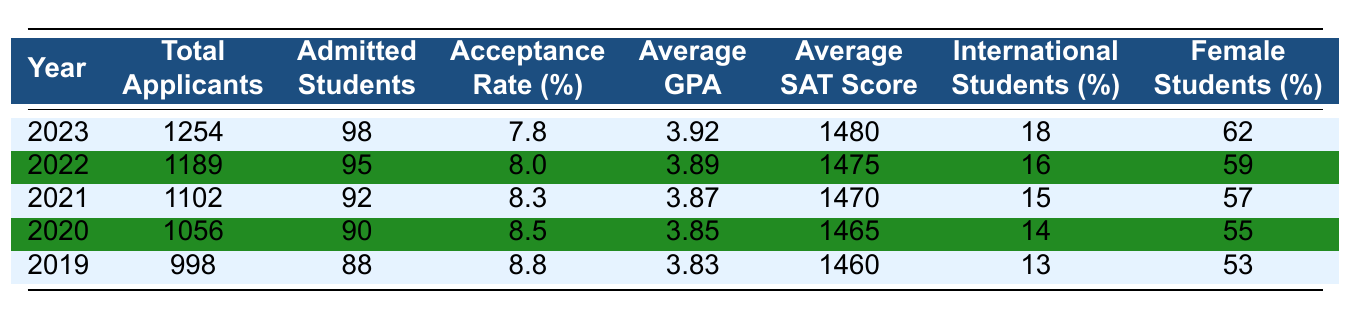What was the acceptance rate in 2023? The acceptance rate for 2023 is provided directly in the table under the corresponding column. It states 7.8%.
Answer: 7.8% How many total applicants were there in 2021? The number of total applicants for the year 2021 is listed directly in the table. It shows 1102 applicants.
Answer: 1102 What is the average GPA of admitted students in 2020? The average GPA for admitted students in 2020 is listed in the table as 3.85.
Answer: 3.85 What percentage of the students admitted in 2022 were female? The table specifies that 59% of the admitted students in 2022 were female.
Answer: 59% What was the total number of admitted students over the last five years? To find the total number of admitted students, sum the admitted students for all years: (98 + 95 + 92 + 90 + 88) = 463.
Answer: 463 What was the trend in acceptance rates from 2019 to 2023? By comparing the acceptance rates from each year in the table: 8.8% (2019), 8.5% (2020), 8.3% (2021), 8.0% (2022), and 7.8% (2023), we see a decreasing trend in acceptance rates over these years.
Answer: Decreasing How much did the average SAT score increase from 2019 to 2023? The average SAT score in 2019 was 1460 and in 2023 it was 1480. The increase is calculated as 1480 - 1460 = 20.
Answer: 20 What is the percentage of international students in 2022 compared to 2023? The percentage of international students in 2022 is 16% and in 2023 it is 18%. Comparing these, 18% (2023) - 16% (2022) = 2% increase but the question asks for the comparison. So, 18% is higher than 16%.
Answer: Yes Calculate the average acceptance rate over the last 5 years. The acceptance rates for the years are 7.8%, 8.0%, 8.3%, 8.5%, and 8.8%. To find the average: (7.8 + 8.0 + 8.3 + 8.5 + 8.8) / 5 = 8.24%.
Answer: 8.24% Was the average GPA of admitted students higher in 2023 than in 2020? The average GPA in 2023 is 3.92 and in 2020 it is 3.85. Since 3.92 > 3.85, the average GPA in 2023 is higher than that in 2020.
Answer: Yes If the percentage of female students admitted in 2019 was 53%, how much more was it in 2023? The percentage of female students in 2023 is 62% and in 2019 it was 53%. The difference is 62% - 53% = 9%.
Answer: 9% 